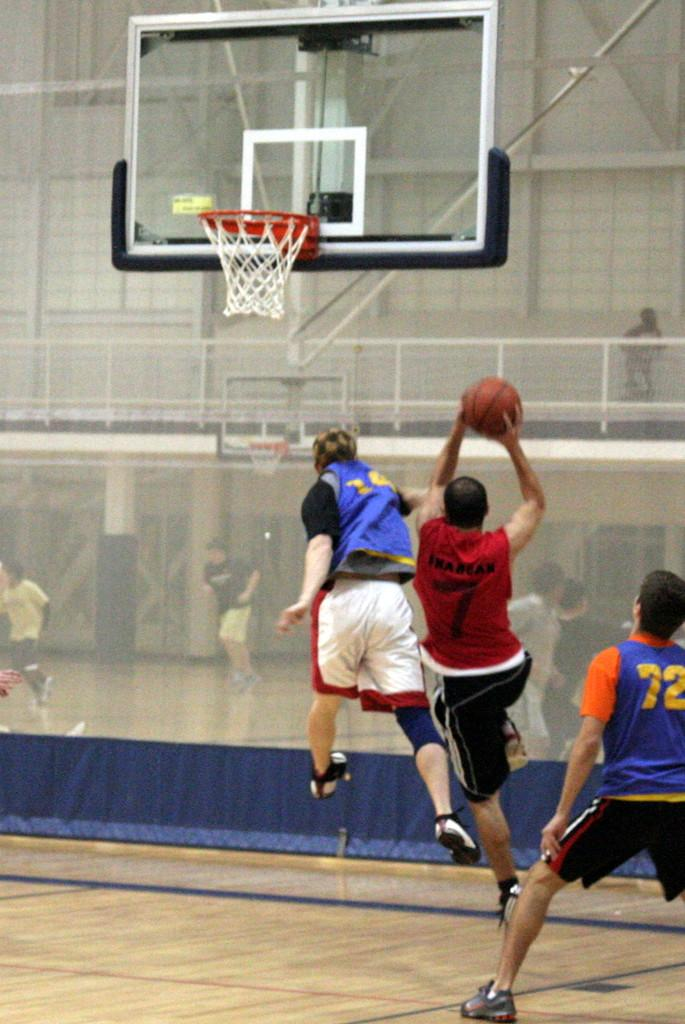What are the people in the image doing? The people in the image are in motion, which suggests they might be playing a game or engaging in some form of physical activity. What object is being held by one of the people? One person is holding a ball in the image. What type of game might be being played in the image? The presence of a basketball hoop and a ball suggests that basketball might be the game being played. Can you describe the basketball hoop and its associated net? The basketball hoop has a net attached to it, and people are visible through the net. What architectural features can be seen in the image? There is a railing, a pillar, and a wall visible in the image. How many cows are visible through the net in the image? There are no cows visible through the net in the image; only people and a basketball hoop can be seen. What type of key is being used to unlock the basketball hoop in the image? There is no key present in the image, and the basketball hoop is not locked. 